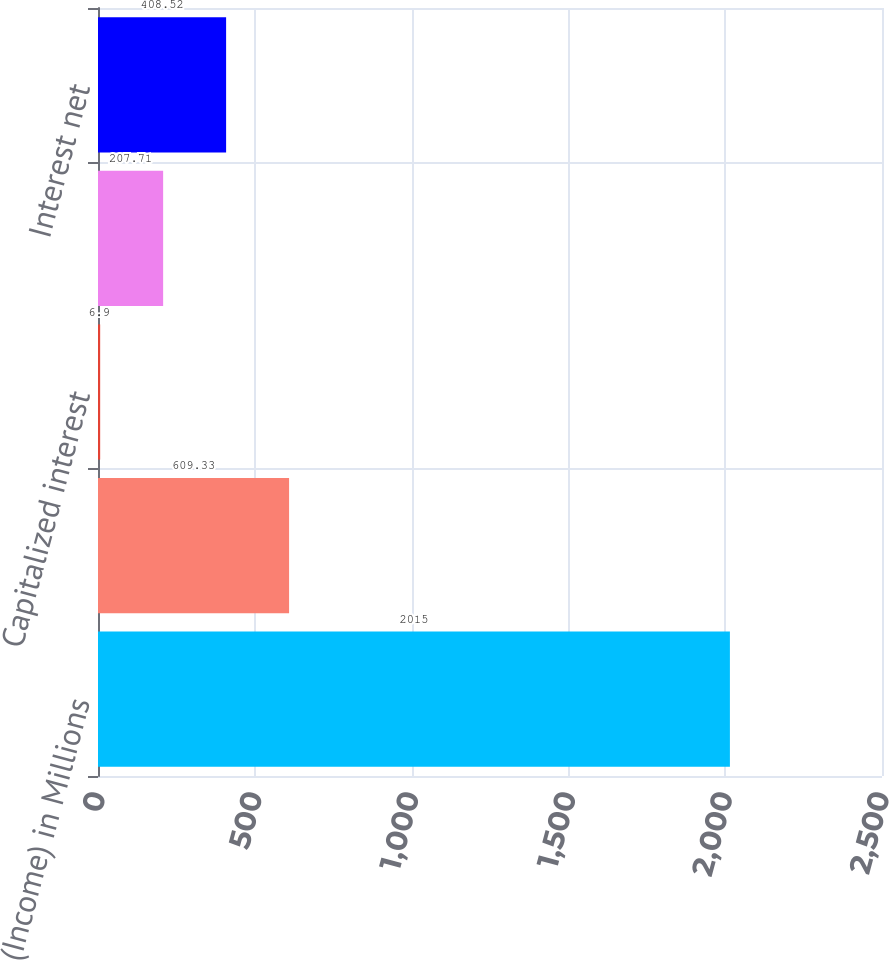Convert chart to OTSL. <chart><loc_0><loc_0><loc_500><loc_500><bar_chart><fcel>Expense (Income) in Millions<fcel>Interest expense<fcel>Capitalized interest<fcel>Interest income<fcel>Interest net<nl><fcel>2015<fcel>609.33<fcel>6.9<fcel>207.71<fcel>408.52<nl></chart> 